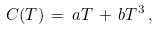Convert formula to latex. <formula><loc_0><loc_0><loc_500><loc_500>C ( T ) \, = \, a T \, + \, b T ^ { 3 } \, ,</formula> 